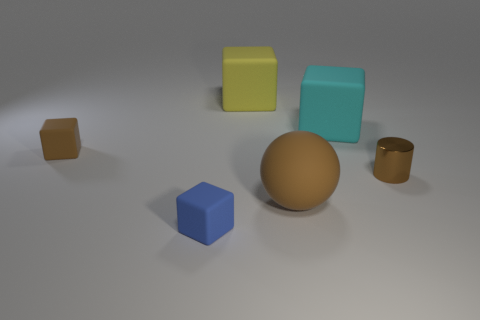There is a large cyan matte object; is it the same shape as the tiny brown object left of the tiny brown shiny thing?
Your response must be concise. Yes. There is a brown ball; are there any tiny brown blocks in front of it?
Offer a terse response. No. What is the material of the cube that is the same color as the metal cylinder?
Make the answer very short. Rubber. Does the cyan thing have the same size as the brown matte thing that is on the right side of the yellow matte thing?
Offer a terse response. Yes. Are there any small cubes that have the same color as the cylinder?
Keep it short and to the point. Yes. Are there any brown metallic things of the same shape as the large cyan rubber object?
Offer a terse response. No. The small thing that is both behind the blue matte object and to the left of the large cyan matte block has what shape?
Offer a terse response. Cube. How many large brown things have the same material as the cyan thing?
Your answer should be very brief. 1. Are there fewer tiny metal objects behind the large yellow matte cube than red metallic cubes?
Offer a terse response. No. Is there a brown sphere behind the brown rubber thing that is on the left side of the yellow block?
Ensure brevity in your answer.  No. 